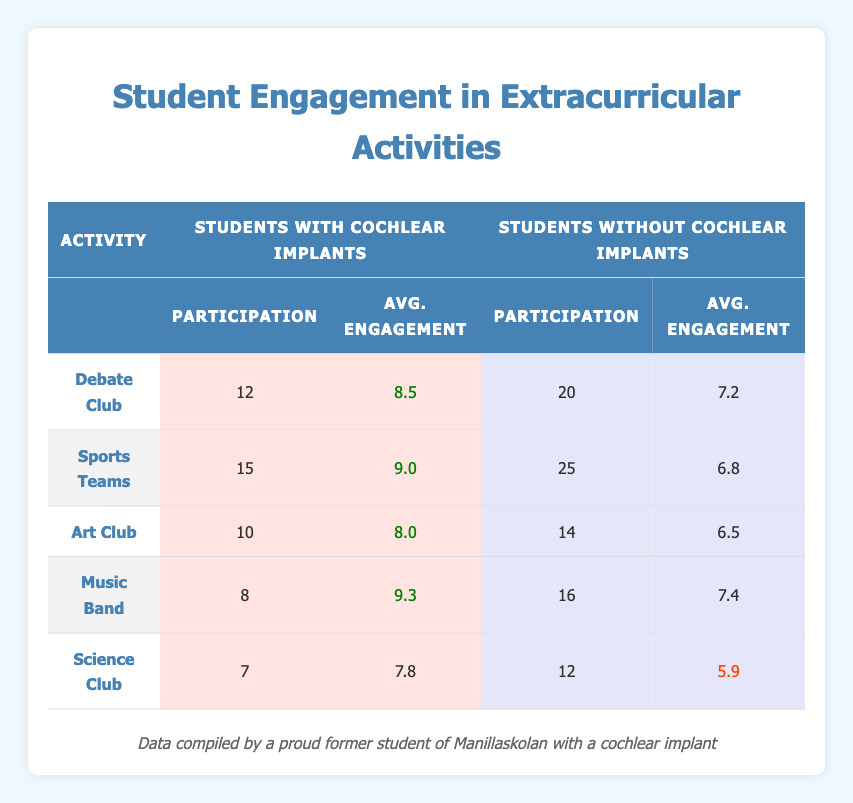What is the average engagement level for students with cochlear implants in the Sports Teams activity? The average engagement level for students with cochlear implants in Sports Teams is listed in the table as 9.0.
Answer: 9.0 How many students without cochlear implants participated in the Music Band? The participation count for students without cochlear implants in Music Band is shown as 16 in the table.
Answer: 16 Which extracurricular activity had the highest average engagement level for students with cochlear implants? In the table, the Music Band has the highest average engagement level of 9.3 for students with cochlear implants, compared to other activities.
Answer: Music Band What is the difference in average engagement levels between students with cochlear implants and those without in the Debate Club? For the Debate Club, the average engagement level for students with cochlear implants is 8.5, and for those without, it is 7.2. The difference is 8.5 - 7.2 = 1.3.
Answer: 1.3 Did more students participate in the Science Club than in the Art Club amongst those with cochlear implants? The participation counts for the Science Club and Art Club are 7 and 10, respectively, for students with cochlear implants. Since 7 is less than 10, the answer is no.
Answer: No What is the total participation count for students with cochlear implants across all activities? To find the total, add the participation counts for each activity for those with cochlear implants: 12 (Debate Club) + 15 (Sports Teams) + 10 (Art Club) + 8 (Music Band) + 7 (Science Club) = 52.
Answer: 52 Are the average engagement levels higher for students with cochlear implants compared to those without in every activity? In the table, students with cochlear implants have higher average engagement levels in all activities: 8.5 vs 7.2 in Debate Club, 9.0 vs 6.8 in Sports Teams, 8.0 vs 6.5 in Art Club, 9.3 vs 7.4 in Music Band, and 7.8 vs 5.9 in Science Club, confirming the statement is true.
Answer: Yes Which group has a higher engagement level in Science Club, and by how much? For the Science Club, students with cochlear implants have an avg engagement level of 7.8 while students without have 5.9. The difference is 7.8 - 5.9 = 1.9, so students with cochlear implants have the higher engagement level by 1.9.
Answer: 1.9 